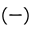<formula> <loc_0><loc_0><loc_500><loc_500>( - )</formula> 